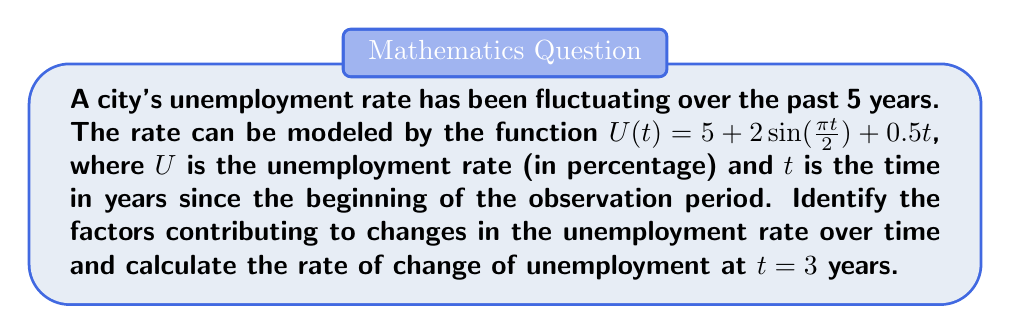Can you answer this question? To analyze the factors contributing to changes in the unemployment rate and calculate the rate of change, we'll follow these steps:

1) Identify the components of the function:
   $U(t) = 5 + 2\sin(\frac{\pi t}{2}) + 0.5t$

   - Constant term: 5 (base unemployment rate)
   - Cyclical component: $2\sin(\frac{\pi t}{2})$ (seasonal or business cycle fluctuations)
   - Linear trend: $0.5t$ (long-term trend)

2) To find the rate of change at $t = 3$, we need to differentiate $U(t)$ with respect to $t$:

   $\frac{dU}{dt} = 2 \cdot \frac{\pi}{2} \cos(\frac{\pi t}{2}) + 0.5$

3) Evaluate $\frac{dU}{dt}$ at $t = 3$:

   $\frac{dU}{dt}|_{t=3} = 2 \cdot \frac{\pi}{2} \cos(\frac{\pi \cdot 3}{2}) + 0.5$
                         $= \pi \cos(\frac{3\pi}{2}) + 0.5$
                         $= \pi \cdot 0 + 0.5$
                         $= 0.5$

The rate of change at $t = 3$ is 0.5 percentage points per year, which is solely due to the linear trend component. The cyclical component's contribution is zero at this point.
Answer: Factors: base rate (5%), cyclical fluctuations ($2\sin(\frac{\pi t}{2})$), linear trend ($0.5t$). Rate of change at $t=3$: 0.5 percentage points/year. 